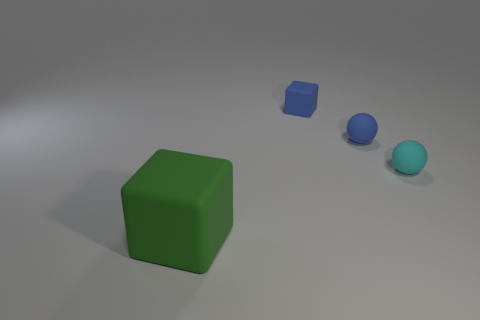What shape is the large green object that is made of the same material as the small cyan ball?
Keep it short and to the point. Cube. How many things are either matte cubes right of the big object or big blue metallic cylinders?
Your answer should be compact. 1. Are there fewer large cubes than blue things?
Your response must be concise. Yes. There is a object that is behind the blue matte thing that is right of the rubber cube behind the big thing; what shape is it?
Keep it short and to the point. Cube. There is a small matte thing that is the same color as the small rubber block; what is its shape?
Your response must be concise. Sphere. Are any rubber blocks visible?
Your answer should be compact. Yes. There is a blue block; is it the same size as the blue rubber thing that is on the right side of the blue block?
Your answer should be very brief. Yes. There is a rubber sphere that is behind the tiny cyan ball; is there a small blue block that is in front of it?
Offer a very short reply. No. There is a object that is left of the blue sphere and behind the green cube; what material is it?
Your response must be concise. Rubber. There is a matte block to the right of the cube to the left of the cube that is behind the green matte object; what color is it?
Provide a succinct answer. Blue. 